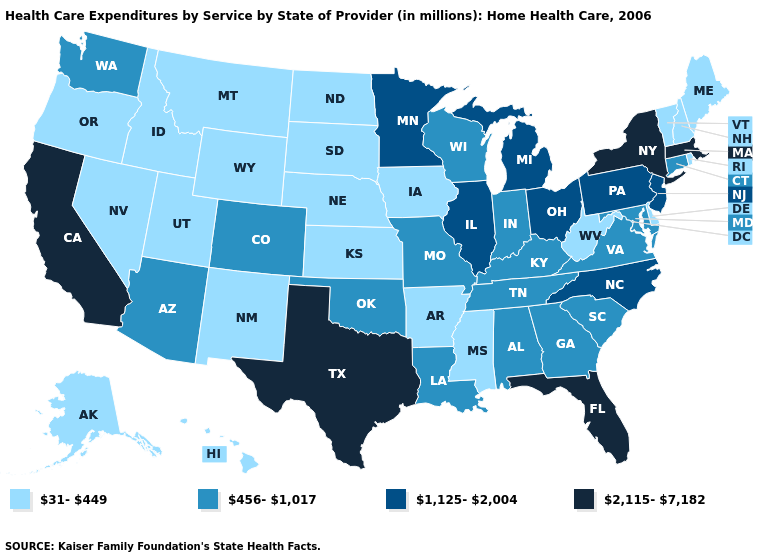Does Georgia have a lower value than Idaho?
Give a very brief answer. No. What is the value of Alabama?
Answer briefly. 456-1,017. Does California have the lowest value in the West?
Quick response, please. No. Among the states that border California , which have the highest value?
Concise answer only. Arizona. Does Florida have the highest value in the USA?
Concise answer only. Yes. What is the value of New Jersey?
Short answer required. 1,125-2,004. What is the value of Hawaii?
Keep it brief. 31-449. Which states hav the highest value in the South?
Quick response, please. Florida, Texas. What is the value of Washington?
Be succinct. 456-1,017. Which states have the lowest value in the South?
Keep it brief. Arkansas, Delaware, Mississippi, West Virginia. Name the states that have a value in the range 1,125-2,004?
Keep it brief. Illinois, Michigan, Minnesota, New Jersey, North Carolina, Ohio, Pennsylvania. Which states have the highest value in the USA?
Quick response, please. California, Florida, Massachusetts, New York, Texas. What is the value of Louisiana?
Write a very short answer. 456-1,017. Does the map have missing data?
Give a very brief answer. No. Among the states that border Massachusetts , which have the lowest value?
Write a very short answer. New Hampshire, Rhode Island, Vermont. 